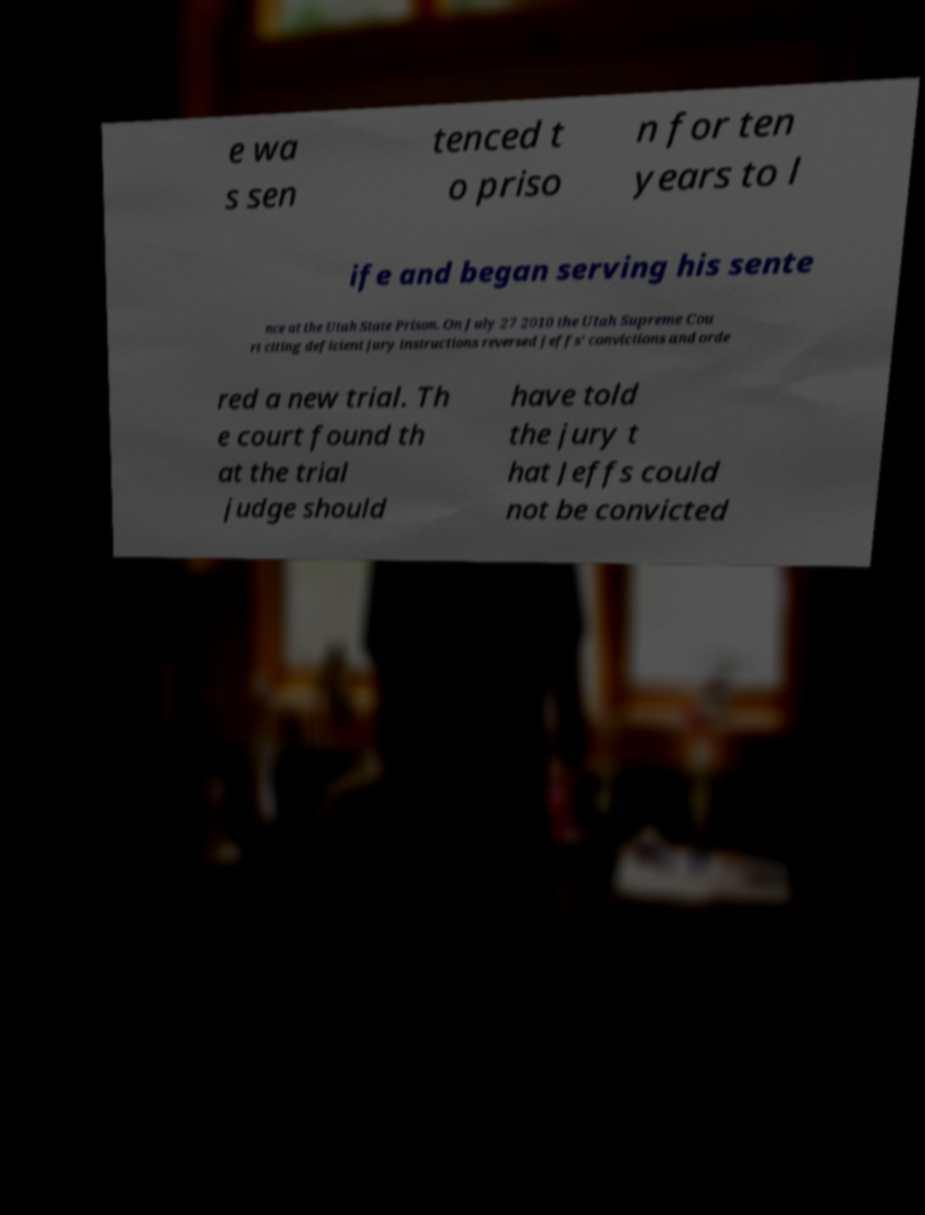Please identify and transcribe the text found in this image. e wa s sen tenced t o priso n for ten years to l ife and began serving his sente nce at the Utah State Prison. On July 27 2010 the Utah Supreme Cou rt citing deficient jury instructions reversed Jeffs' convictions and orde red a new trial. Th e court found th at the trial judge should have told the jury t hat Jeffs could not be convicted 